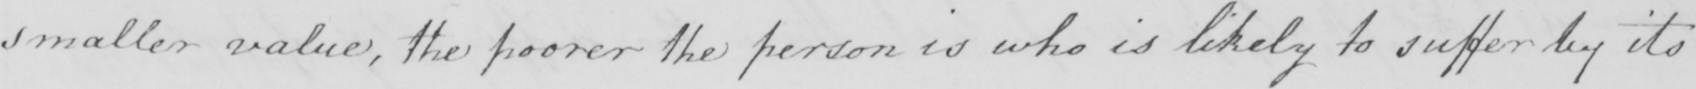Please transcribe the handwritten text in this image. smaller value , the poorer the person is who is likely to suffer by its 